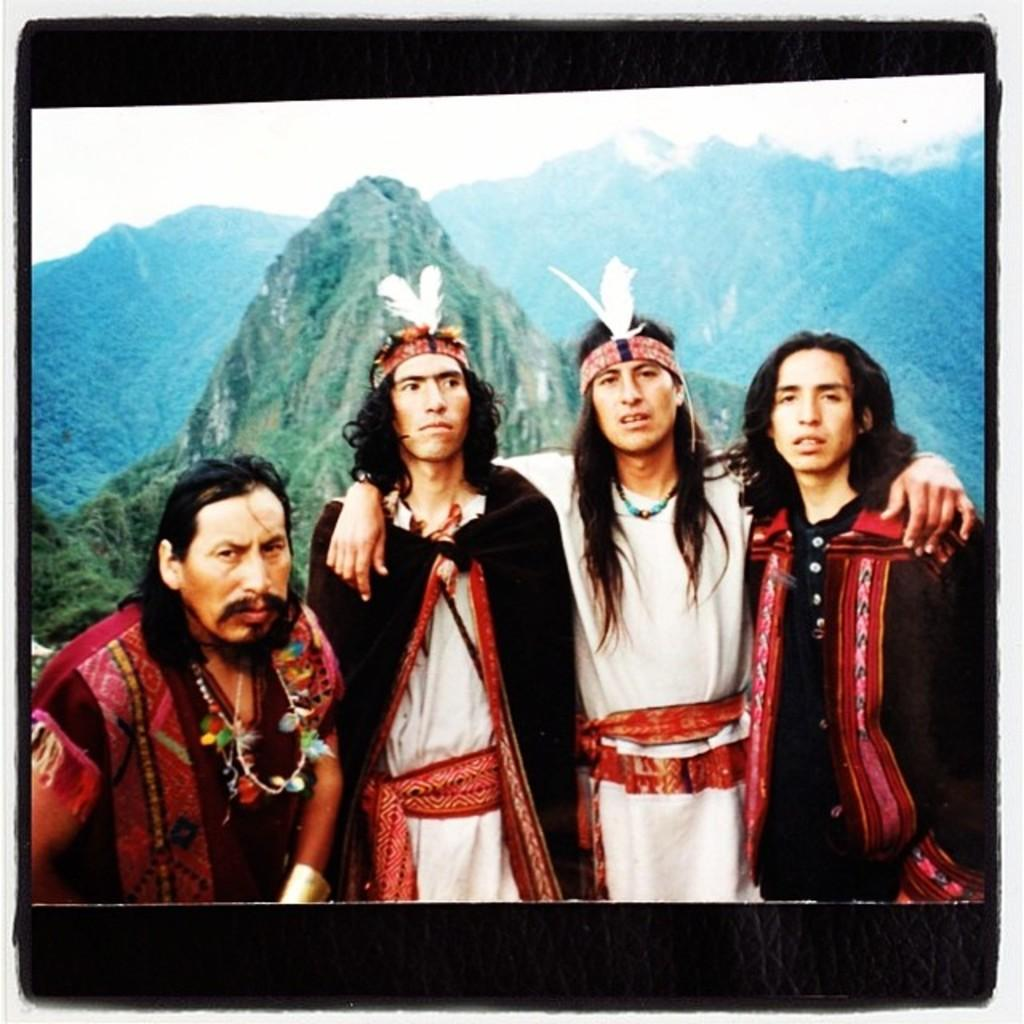How many people are in the image? There are four men in the image. What are the men wearing? The men are wearing traditional dress. What can be seen in the background of the image? Mountains and the sky are visible in the background of the image. What type of account do the men have in the image? There is no mention of an account in the image, as it features four men wearing traditional dress with mountains and the sky visible in the background. 